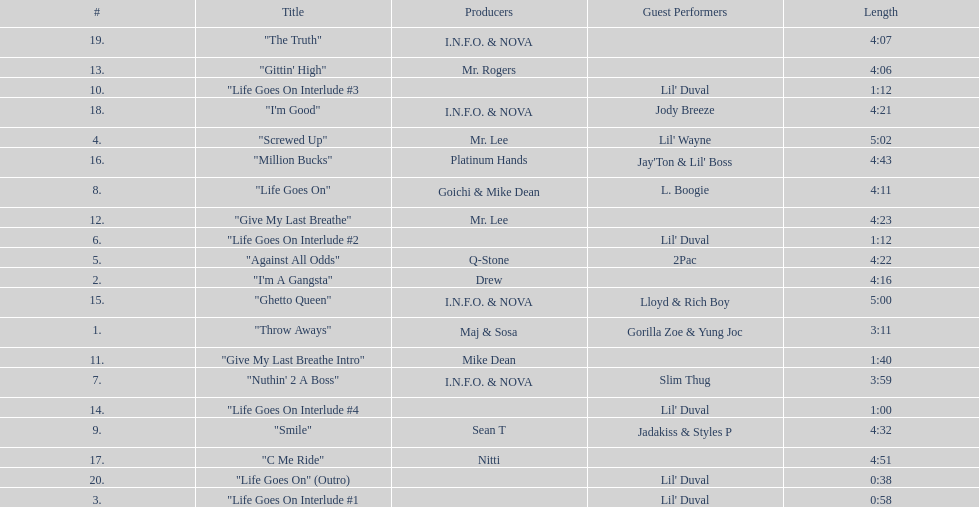Which tracks feature the same producer(s) in consecutive order on this album? "I'm Good", "The Truth". 